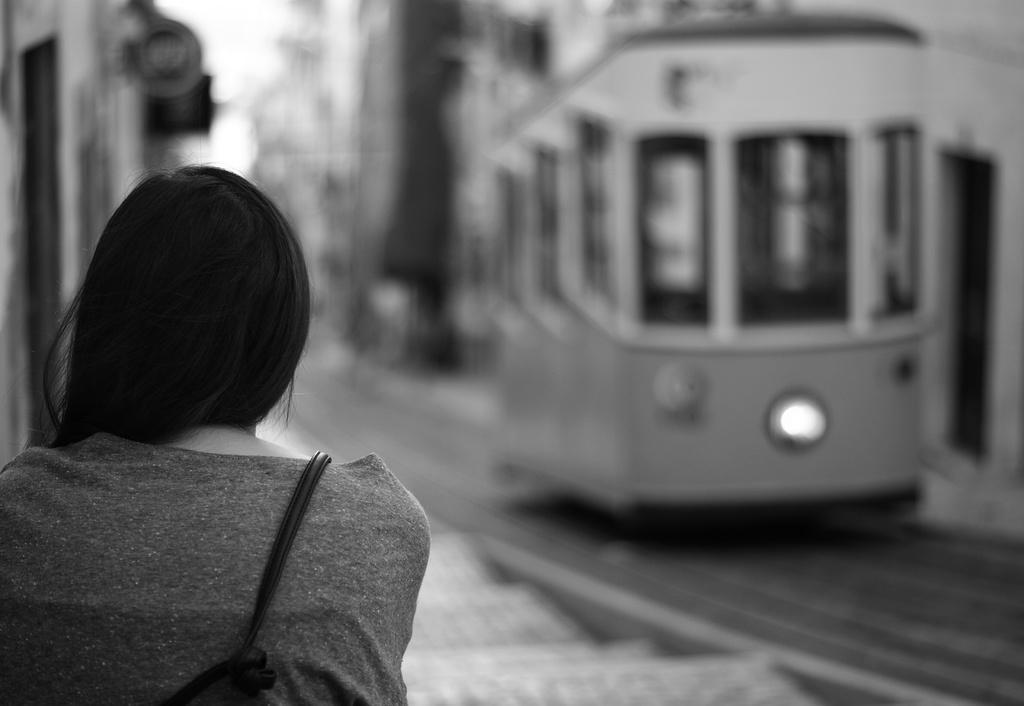Describe this image in one or two sentences. This is a black and white image. In the foreground of the image there is a lady. In the background of the image there are buildings. There is a train. 